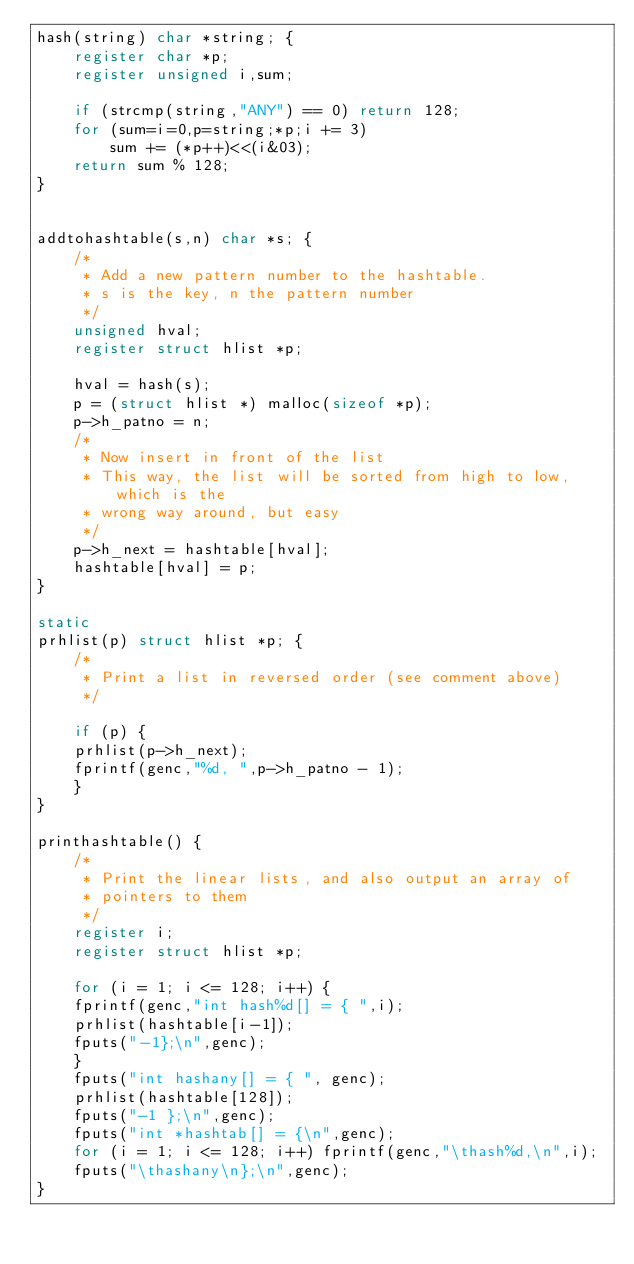<code> <loc_0><loc_0><loc_500><loc_500><_C_>hash(string) char *string; {
	register char *p;
	register unsigned i,sum;

	if (strcmp(string,"ANY") == 0) return 128;
	for (sum=i=0,p=string;*p;i += 3)
		sum += (*p++)<<(i&03);
	return sum % 128;
}


addtohashtable(s,n) char *s; {
    /*
     * Add a new pattern number to the hashtable. 
     * s is the key, n the pattern number
     */
    unsigned hval;
    register struct hlist *p;

    hval = hash(s);
    p = (struct hlist *) malloc(sizeof *p);
    p->h_patno = n;
    /*
     * Now insert in front of the list 
     * This way, the list will be sorted from high to low, which is the
     * wrong way around, but easy
     */
    p->h_next = hashtable[hval];
    hashtable[hval] = p;
}

static
prhlist(p) struct hlist *p; {
    /*
     * Print a list in reversed order (see comment above)
     */

    if (p) {
	prhlist(p->h_next);
	fprintf(genc,"%d, ",p->h_patno - 1);
    }
}
 
printhashtable() {
    /*
     * Print the linear lists, and also output an array of
     * pointers to them
     */
    register i;
    register struct hlist *p;

    for (i = 1; i <= 128; i++) {
	fprintf(genc,"int hash%d[] = { ",i);
	prhlist(hashtable[i-1]);
	fputs("-1};\n",genc);
    }
    fputs("int hashany[] = { ", genc);
    prhlist(hashtable[128]);
    fputs("-1 };\n",genc);
    fputs("int *hashtab[] = {\n",genc);
    for (i = 1; i <= 128; i++) fprintf(genc,"\thash%d,\n",i);
    fputs("\thashany\n};\n",genc);
}
</code> 